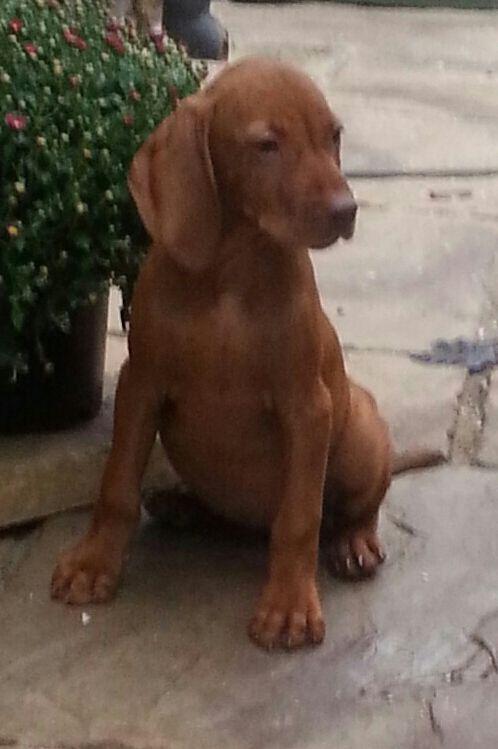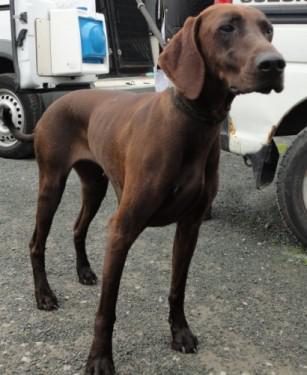The first image is the image on the left, the second image is the image on the right. Considering the images on both sides, is "One brown dog is sitting upright on a wood floor, and the other brown dog is reclining with its body in profile but its head turned to the camera." valid? Answer yes or no. No. The first image is the image on the left, the second image is the image on the right. Examine the images to the left and right. Is the description "A dog in one of the images is sitting on a wooden floor." accurate? Answer yes or no. No. 